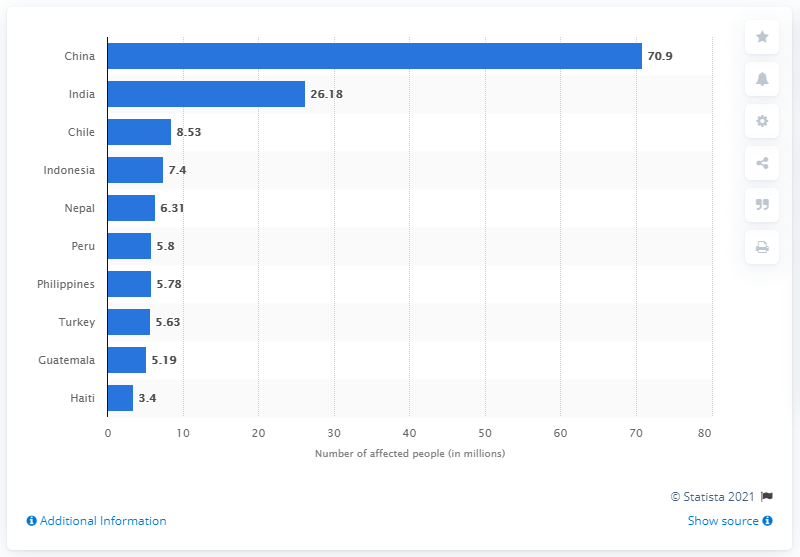Can you compare the earthquake impact on South American countries shown in the image? The chart illustrates that Chile and Peru are the most affected South American countries regarding earthquake impact, with 8.53 million and 5.8 million affected individuals respectively. These numbers reflect the geographical vulnerability of these nations to seismic activity. 